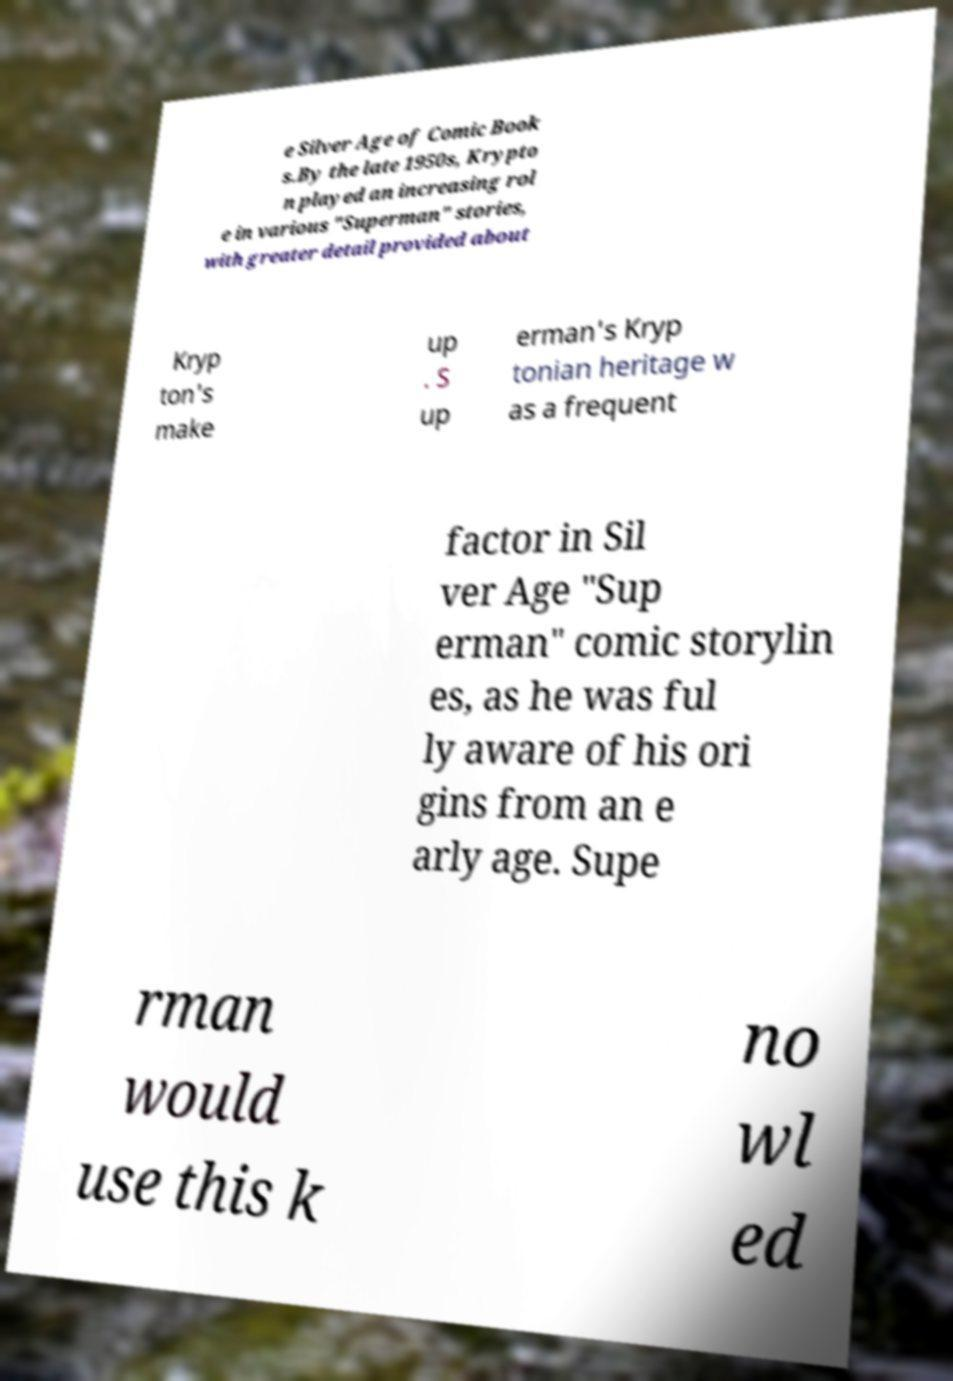What messages or text are displayed in this image? I need them in a readable, typed format. e Silver Age of Comic Book s.By the late 1950s, Krypto n played an increasing rol e in various "Superman" stories, with greater detail provided about Kryp ton's make up . S up erman's Kryp tonian heritage w as a frequent factor in Sil ver Age "Sup erman" comic storylin es, as he was ful ly aware of his ori gins from an e arly age. Supe rman would use this k no wl ed 